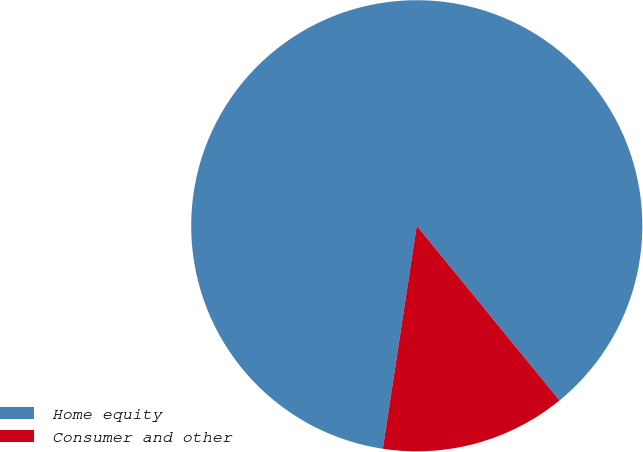<chart> <loc_0><loc_0><loc_500><loc_500><pie_chart><fcel>Home equity<fcel>Consumer and other<nl><fcel>86.69%<fcel>13.31%<nl></chart> 